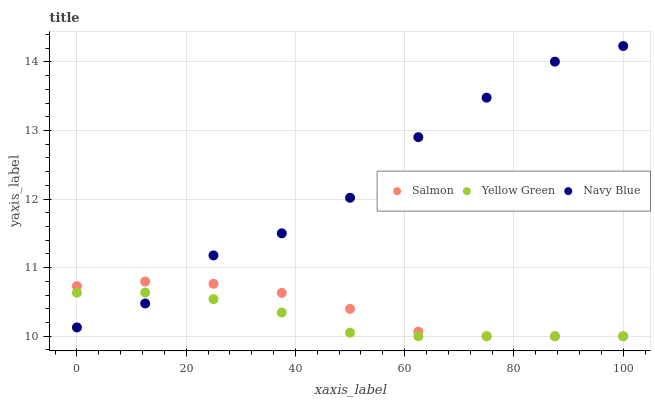Does Yellow Green have the minimum area under the curve?
Answer yes or no. Yes. Does Navy Blue have the maximum area under the curve?
Answer yes or no. Yes. Does Salmon have the minimum area under the curve?
Answer yes or no. No. Does Salmon have the maximum area under the curve?
Answer yes or no. No. Is Yellow Green the smoothest?
Answer yes or no. Yes. Is Navy Blue the roughest?
Answer yes or no. Yes. Is Salmon the smoothest?
Answer yes or no. No. Is Salmon the roughest?
Answer yes or no. No. Does Salmon have the lowest value?
Answer yes or no. Yes. Does Navy Blue have the highest value?
Answer yes or no. Yes. Does Salmon have the highest value?
Answer yes or no. No. Does Yellow Green intersect Navy Blue?
Answer yes or no. Yes. Is Yellow Green less than Navy Blue?
Answer yes or no. No. Is Yellow Green greater than Navy Blue?
Answer yes or no. No. 